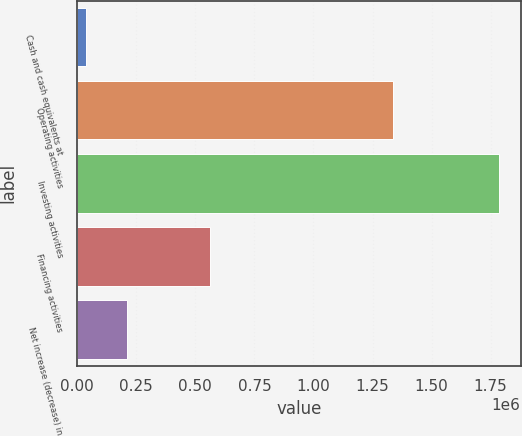Convert chart to OTSL. <chart><loc_0><loc_0><loc_500><loc_500><bar_chart><fcel>Cash and cash equivalents at<fcel>Operating activities<fcel>Investing activities<fcel>Financing activities<fcel>Net increase (decrease) in<nl><fcel>35907<fcel>1.33754e+06<fcel>1.78741e+06<fcel>561358<fcel>211057<nl></chart> 